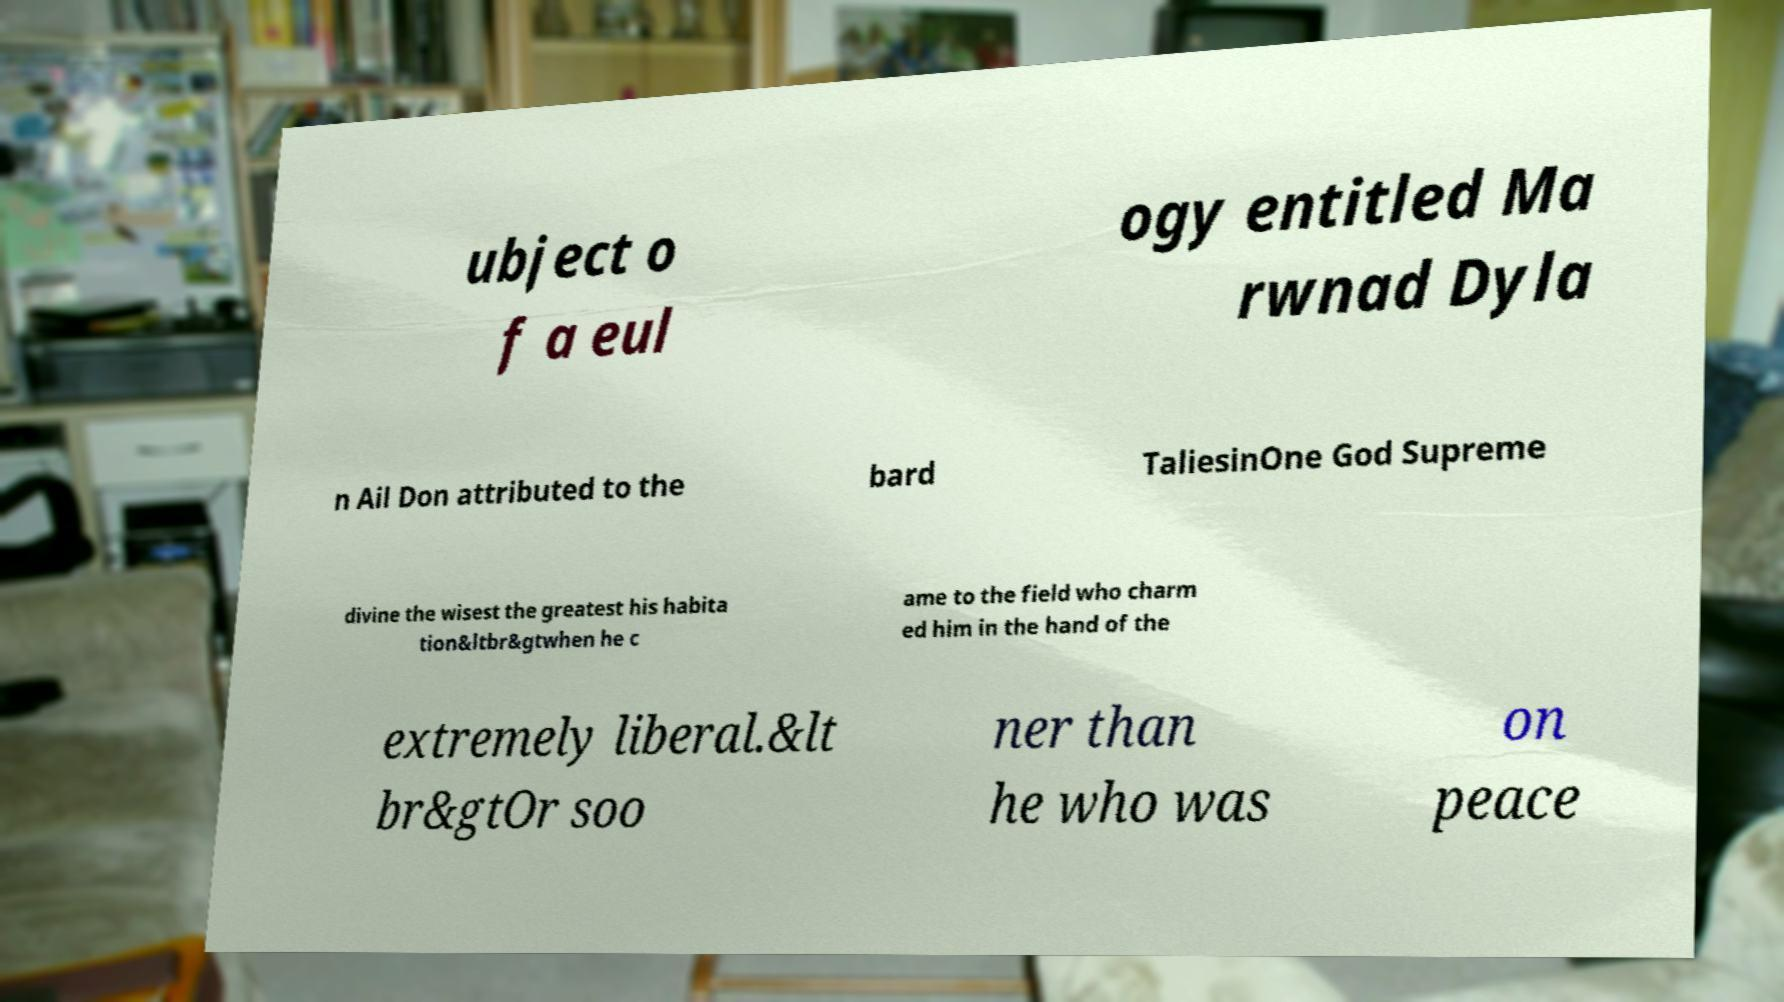For documentation purposes, I need the text within this image transcribed. Could you provide that? ubject o f a eul ogy entitled Ma rwnad Dyla n Ail Don attributed to the bard TaliesinOne God Supreme divine the wisest the greatest his habita tion&ltbr&gtwhen he c ame to the field who charm ed him in the hand of the extremely liberal.&lt br&gtOr soo ner than he who was on peace 